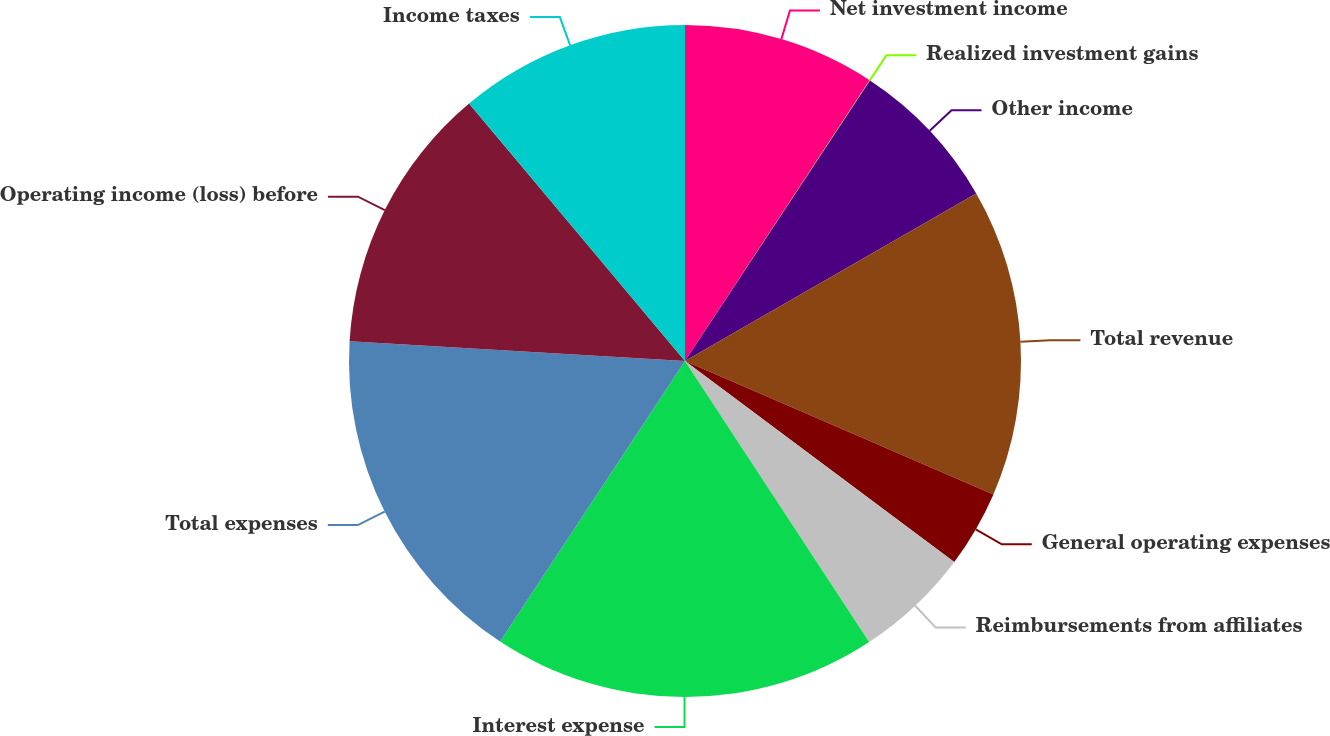Convert chart. <chart><loc_0><loc_0><loc_500><loc_500><pie_chart><fcel>Net investment income<fcel>Realized investment gains<fcel>Other income<fcel>Total revenue<fcel>General operating expenses<fcel>Reimbursements from affiliates<fcel>Interest expense<fcel>Total expenses<fcel>Operating income (loss) before<fcel>Income taxes<nl><fcel>9.26%<fcel>0.02%<fcel>7.41%<fcel>14.81%<fcel>3.71%<fcel>5.56%<fcel>18.51%<fcel>16.66%<fcel>12.96%<fcel>11.11%<nl></chart> 